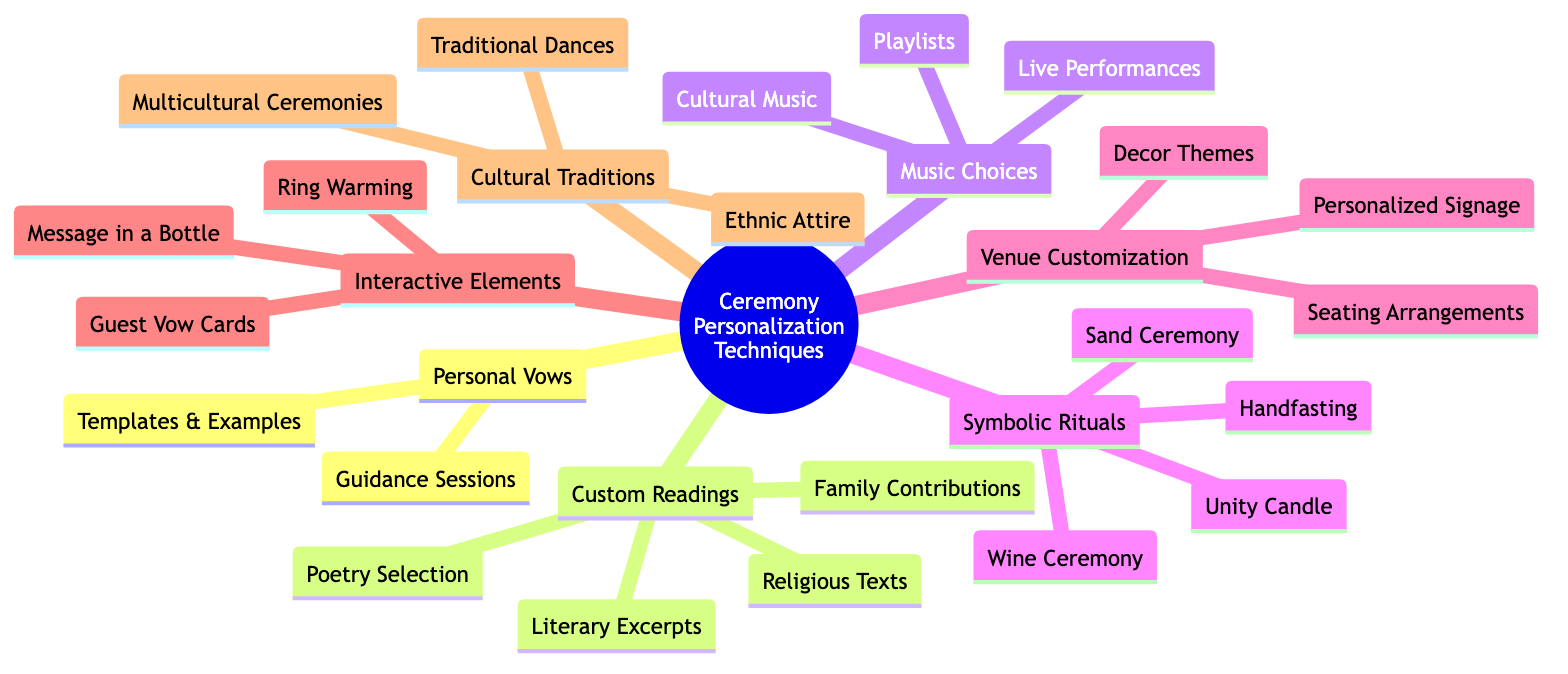What are the sub-elements of Personal Vows? The diagram lists "Guidance Sessions" and "Templates & Examples" under the "Personal Vows" node, indicating these are the specific sub-elements related to this personalization technique.
Answer: Guidance Sessions, Templates & Examples How many main categories are there in the diagram? By counting the primary nodes connected to the root node "Ceremony Personalization Techniques," we find there are seven main categories displayed in the mind map.
Answer: 7 What is one example of a symbolic ritual mentioned? The diagram showcases specific sub-elements under "Symbolic Rituals," like "Unity Candle," which serves as an example of a ritual that can be included in a ceremony.
Answer: Unity Candle Which category includes "Guest Vow Cards"? The "Interactive Elements" category is designated for three sub-elements, including "Guest Vow Cards," which highlights one method to engage guests during the ceremony.
Answer: Interactive Elements How many types of readings are suggested under Custom Readings? Under the "Custom Readings" node, there are four sub-elements listed: "Poetry Selection," "Literary Excerpts," "Religious Texts," and "Family Contributions," totaling up to four distinct types of readings.
Answer: 4 What is a common theme found in the Cultural Traditions category? Among the sub-elements of "Cultural Traditions," "Multicultural Ceremonies," "Ethnic Attire," and "Traditional Dances" are highlighted, all reflecting the diverse cultural aspects that might be incorporated into a wedding ceremony.
Answer: Multicultural Ceremonies Which personalization technique contains the most sub-elements? By examining each main category and counting the sub-elements, "Custom Readings" has the most with four distinct sub-elements, indicating a variety of reading options for personalization.
Answer: Custom Readings Is "Live Performances" listed under Music Choices or Venue Customization? Referring to the diagram, "Live Performances" is categorized under "Music Choices," indicating it’s associated with the selection of music for the ceremony rather than venue elements.
Answer: Music Choices What is a unique feature of the Interactive Elements category? The sub-elements of "Interactive Elements," such as "Message in a Bottle" and "Ring Warming," suggest that this category is designed to foster engagement and participation from guests, making the ceremony more interactive.
Answer: Engagement 